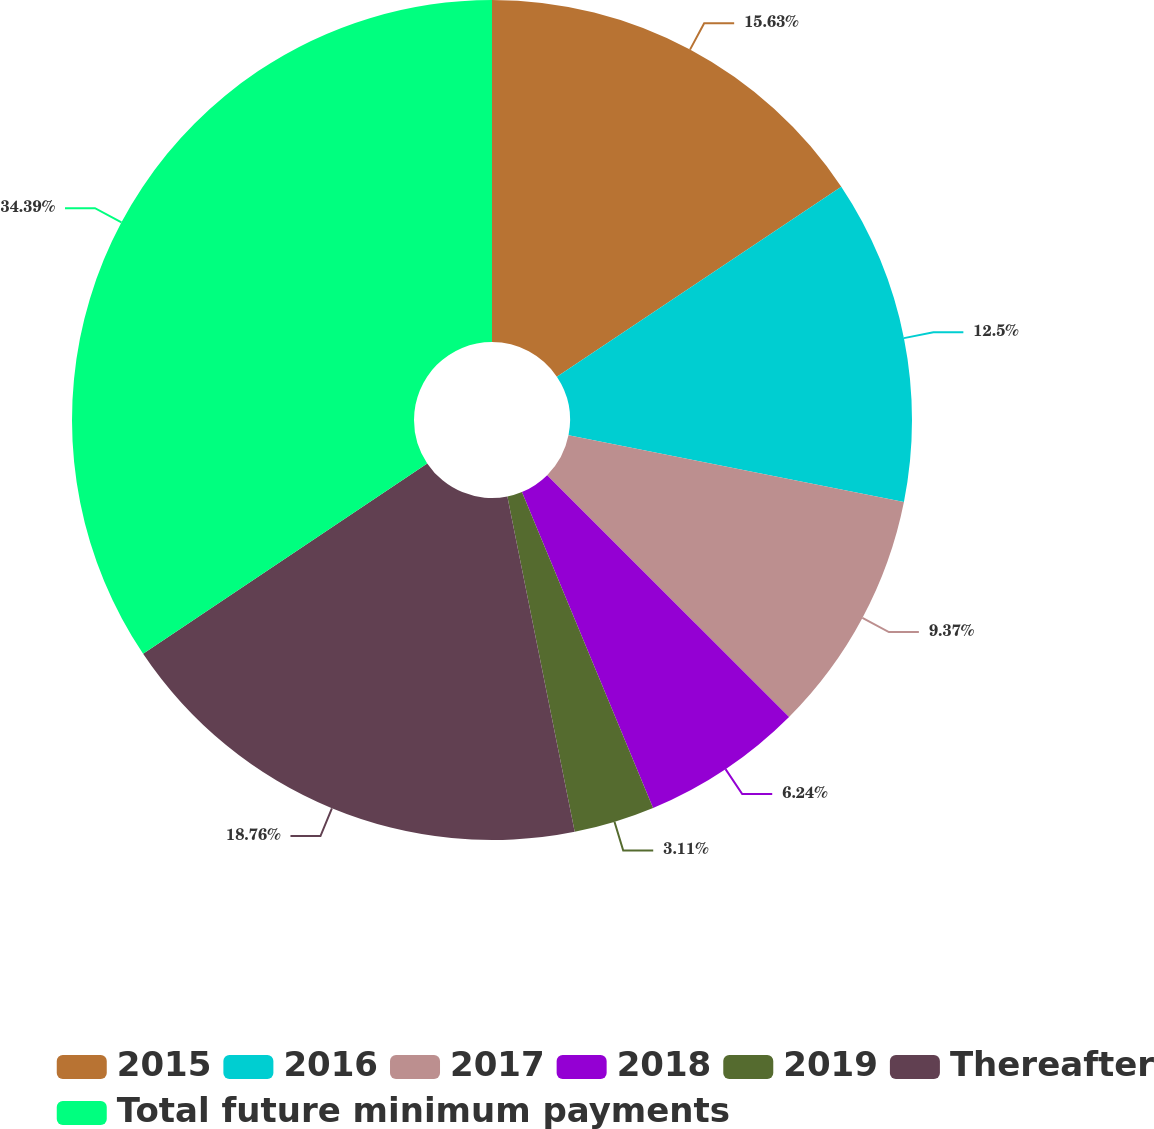<chart> <loc_0><loc_0><loc_500><loc_500><pie_chart><fcel>2015<fcel>2016<fcel>2017<fcel>2018<fcel>2019<fcel>Thereafter<fcel>Total future minimum payments<nl><fcel>15.63%<fcel>12.5%<fcel>9.37%<fcel>6.24%<fcel>3.11%<fcel>18.76%<fcel>34.4%<nl></chart> 